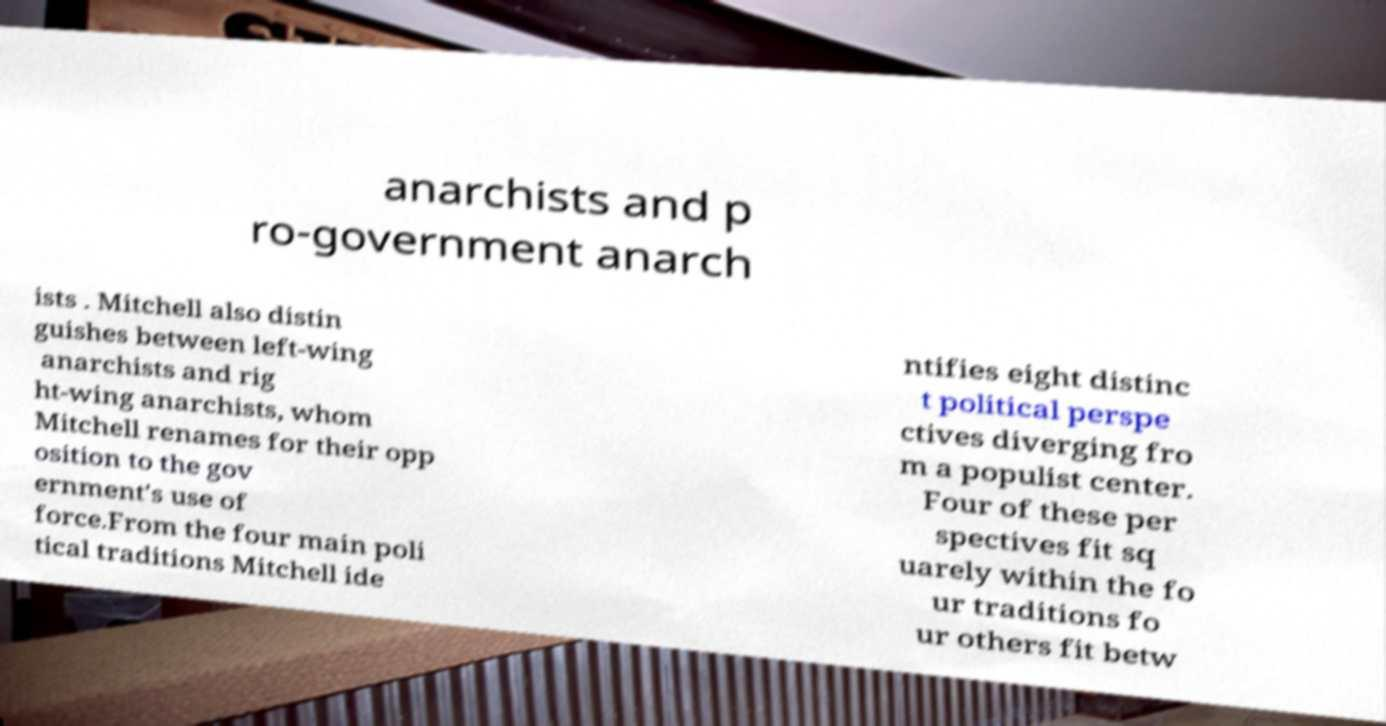Could you extract and type out the text from this image? anarchists and p ro-government anarch ists . Mitchell also distin guishes between left-wing anarchists and rig ht-wing anarchists, whom Mitchell renames for their opp osition to the gov ernment's use of force.From the four main poli tical traditions Mitchell ide ntifies eight distinc t political perspe ctives diverging fro m a populist center. Four of these per spectives fit sq uarely within the fo ur traditions fo ur others fit betw 